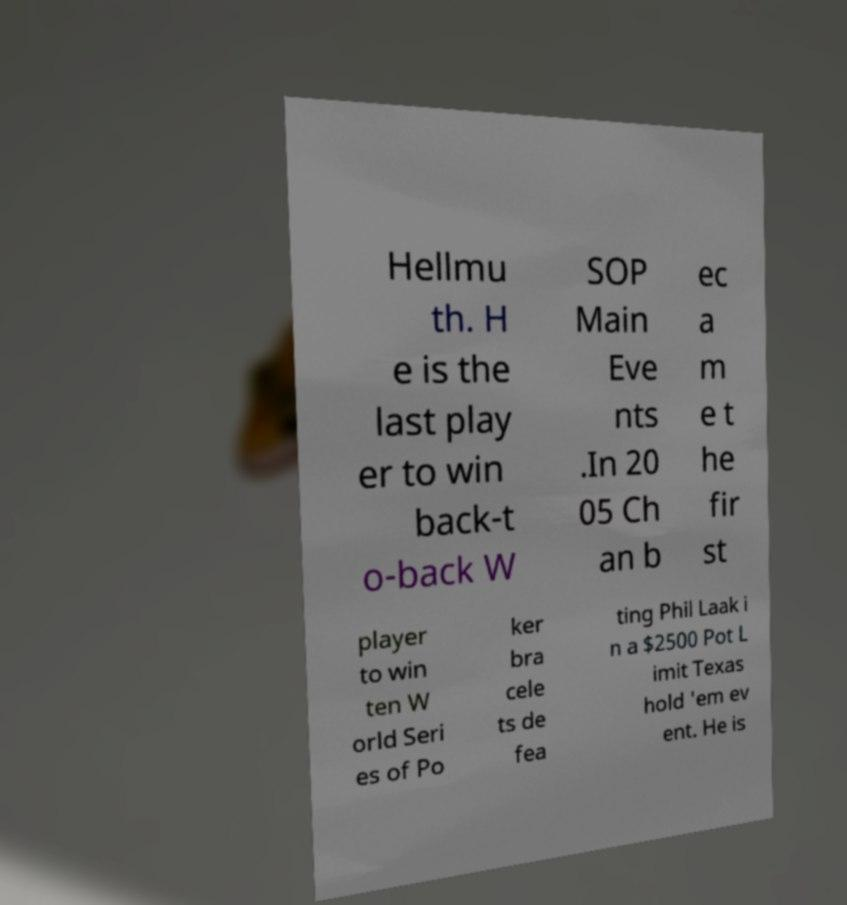Could you assist in decoding the text presented in this image and type it out clearly? Hellmu th. H e is the last play er to win back-t o-back W SOP Main Eve nts .In 20 05 Ch an b ec a m e t he fir st player to win ten W orld Seri es of Po ker bra cele ts de fea ting Phil Laak i n a $2500 Pot L imit Texas hold 'em ev ent. He is 